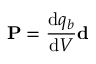<formula> <loc_0><loc_0><loc_500><loc_500>P = { \frac { d q _ { b } } { d V } } d</formula> 